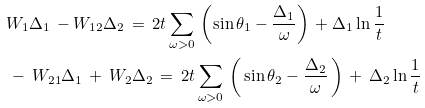<formula> <loc_0><loc_0><loc_500><loc_500>& W _ { 1 } \Delta _ { 1 } \, - W _ { 1 2 } \Delta _ { 2 } \, = \, 2 t \sum _ { \omega > 0 } \, \left ( \sin \theta _ { 1 } - \frac { \Delta _ { 1 } } { \omega } \right ) \, + \Delta _ { 1 } \ln \frac { 1 } { t } \\ & \, - \, W _ { 2 1 } \Delta _ { 1 } \, + \, W _ { 2 } \Delta _ { 2 } \, = \, 2 t \sum _ { \omega > 0 } \, \left ( \, \sin \theta _ { 2 } - \frac { \Delta _ { 2 } } { \omega } \, \right ) \, + \, \Delta _ { 2 } \ln \frac { 1 } { t }</formula> 